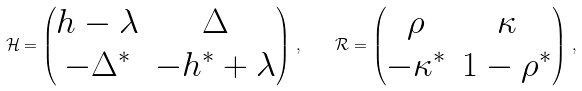Convert formula to latex. <formula><loc_0><loc_0><loc_500><loc_500>\mathcal { H } = \begin{pmatrix} h - \lambda & \Delta \\ - \Delta ^ { * } & - h ^ { * } + \lambda \end{pmatrix} \, , \quad \mathcal { R } = \begin{pmatrix} \rho & \kappa \\ - \kappa ^ { * } & 1 - \rho ^ { * } \end{pmatrix} \, ,</formula> 